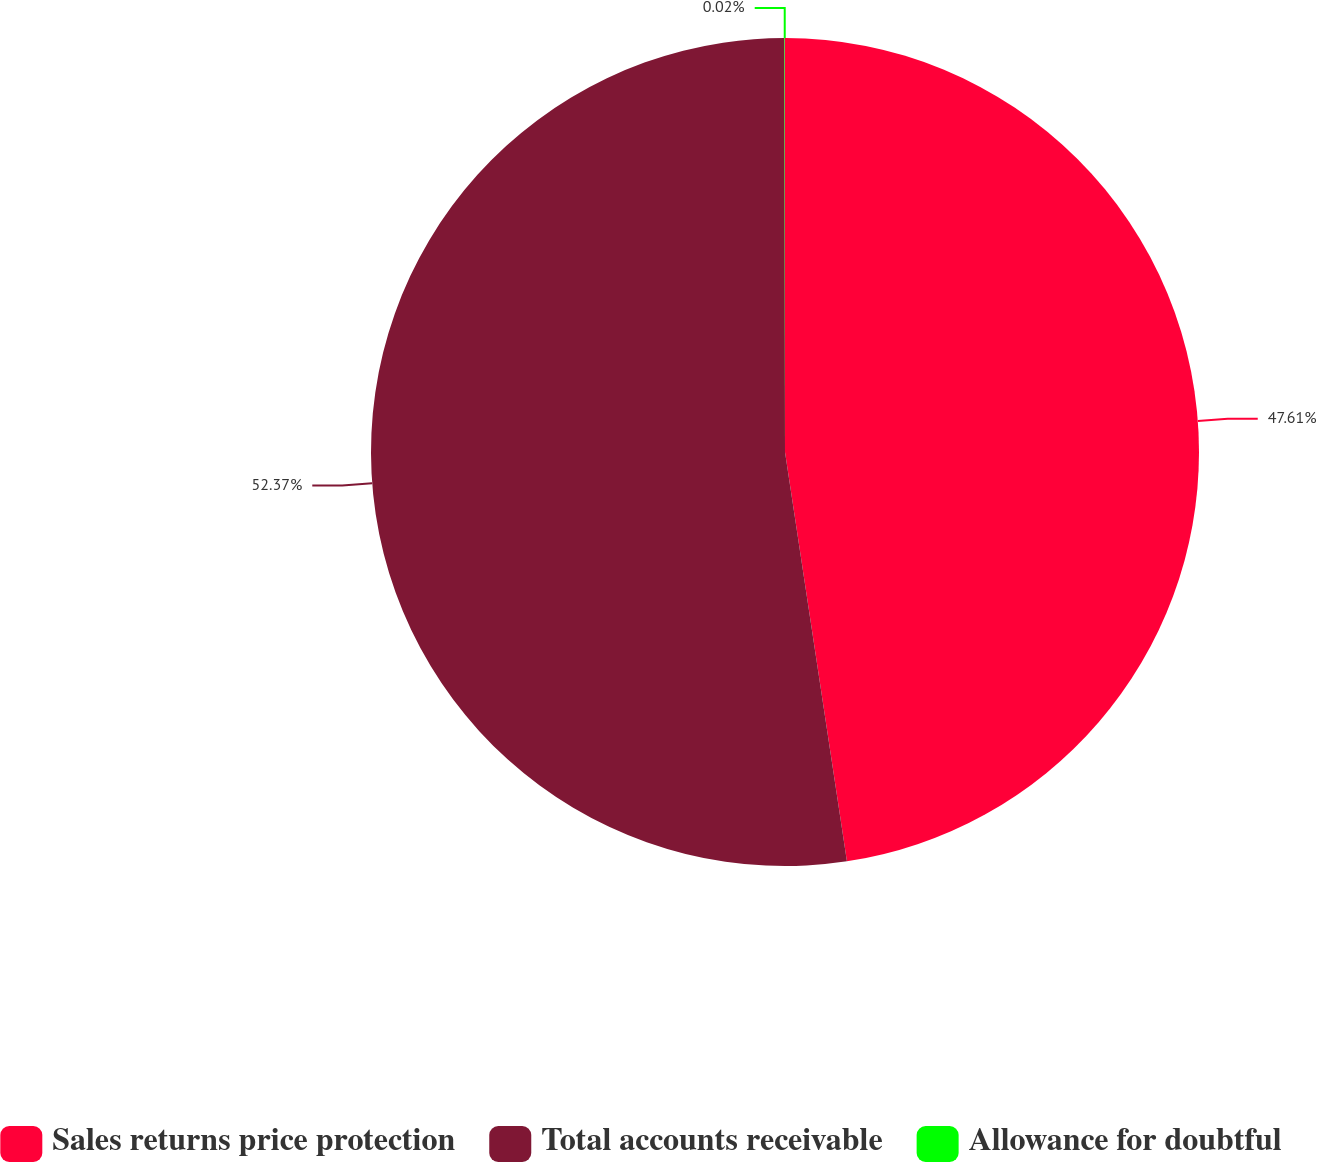Convert chart to OTSL. <chart><loc_0><loc_0><loc_500><loc_500><pie_chart><fcel>Sales returns price protection<fcel>Total accounts receivable<fcel>Allowance for doubtful<nl><fcel>47.61%<fcel>52.37%<fcel>0.02%<nl></chart> 